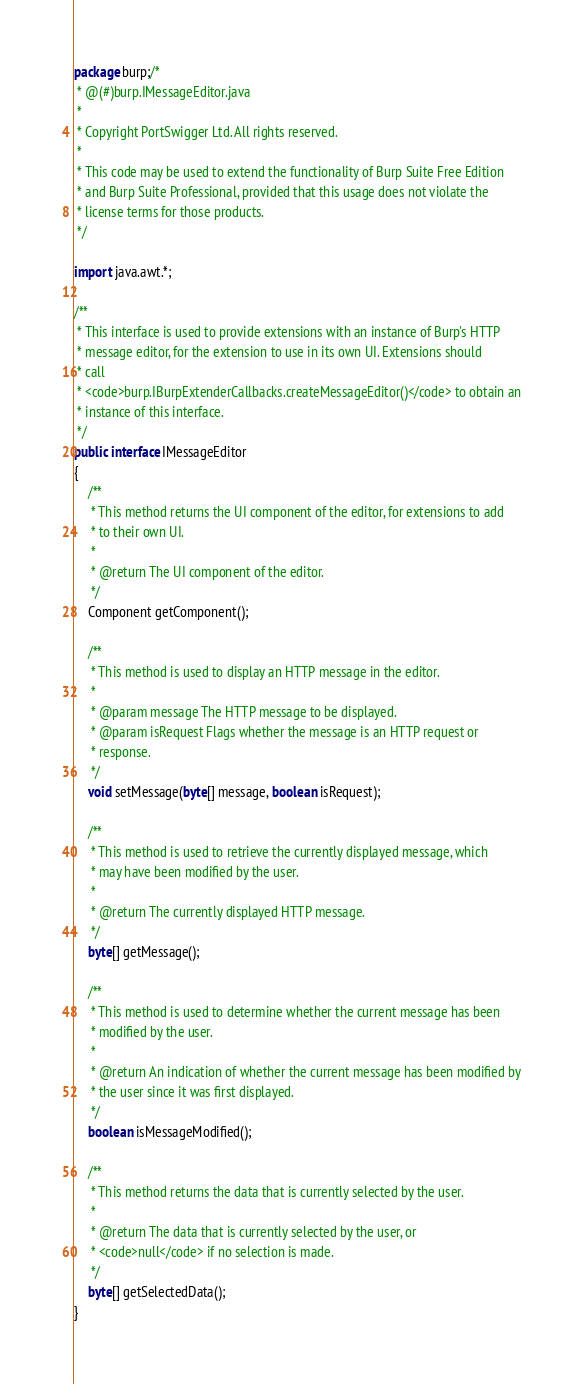Convert code to text. <code><loc_0><loc_0><loc_500><loc_500><_Java_>package burp;/*
 * @(#)burp.IMessageEditor.java
 *
 * Copyright PortSwigger Ltd. All rights reserved.
 *
 * This code may be used to extend the functionality of Burp Suite Free Edition
 * and Burp Suite Professional, provided that this usage does not violate the
 * license terms for those products.
 */

import java.awt.*;

/**
 * This interface is used to provide extensions with an instance of Burp's HTTP
 * message editor, for the extension to use in its own UI. Extensions should
 * call
 * <code>burp.IBurpExtenderCallbacks.createMessageEditor()</code> to obtain an
 * instance of this interface.
 */
public interface IMessageEditor
{
    /**
     * This method returns the UI component of the editor, for extensions to add
     * to their own UI.
     *
     * @return The UI component of the editor.
     */
    Component getComponent();

    /**
     * This method is used to display an HTTP message in the editor.
     *
     * @param message The HTTP message to be displayed.
     * @param isRequest Flags whether the message is an HTTP request or
     * response.
     */
    void setMessage(byte[] message, boolean isRequest);

    /**
     * This method is used to retrieve the currently displayed message, which
     * may have been modified by the user.
     *
     * @return The currently displayed HTTP message.
     */
    byte[] getMessage();

    /**
     * This method is used to determine whether the current message has been
     * modified by the user.
     *
     * @return An indication of whether the current message has been modified by
     * the user since it was first displayed.
     */
    boolean isMessageModified();

    /**
     * This method returns the data that is currently selected by the user.
     *
     * @return The data that is currently selected by the user, or
     * <code>null</code> if no selection is made.
     */
    byte[] getSelectedData();
}
</code> 